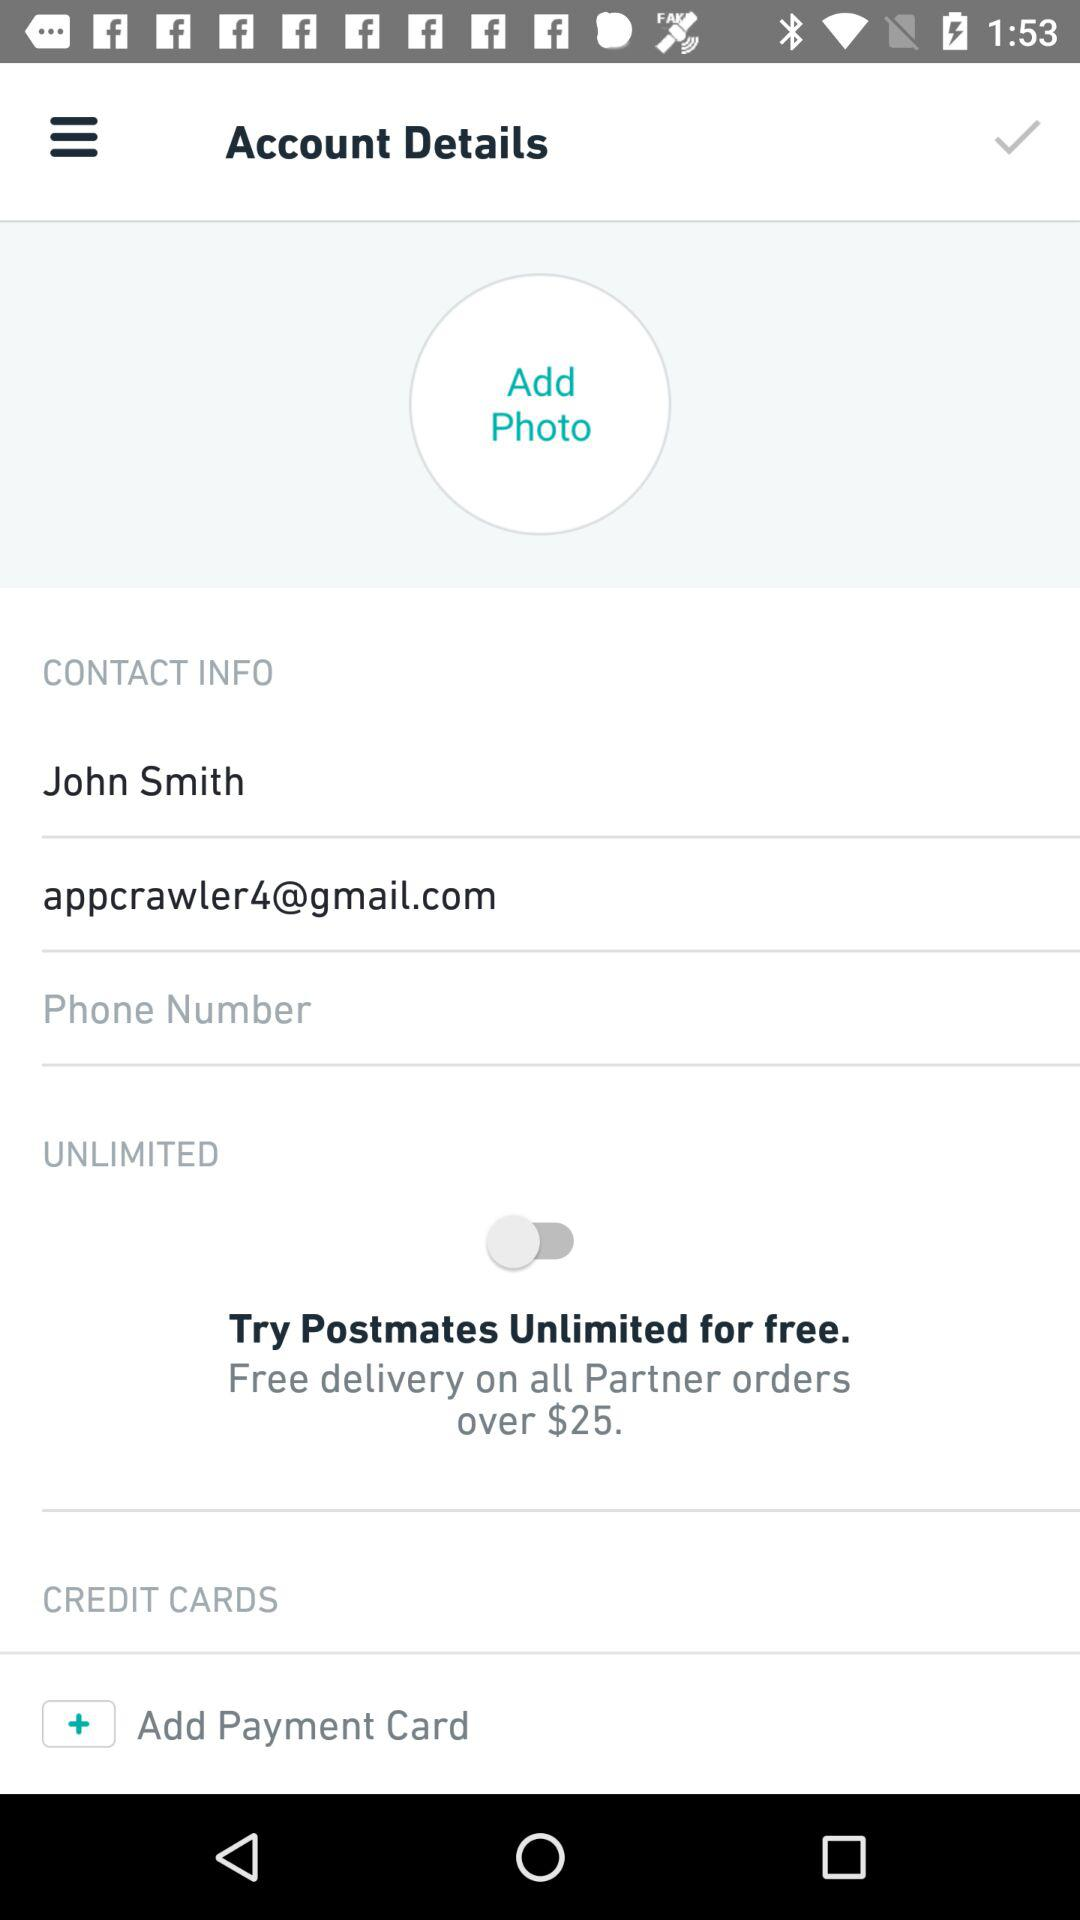Which company's credit card is used?
When the provided information is insufficient, respond with <no answer>. <no answer> 